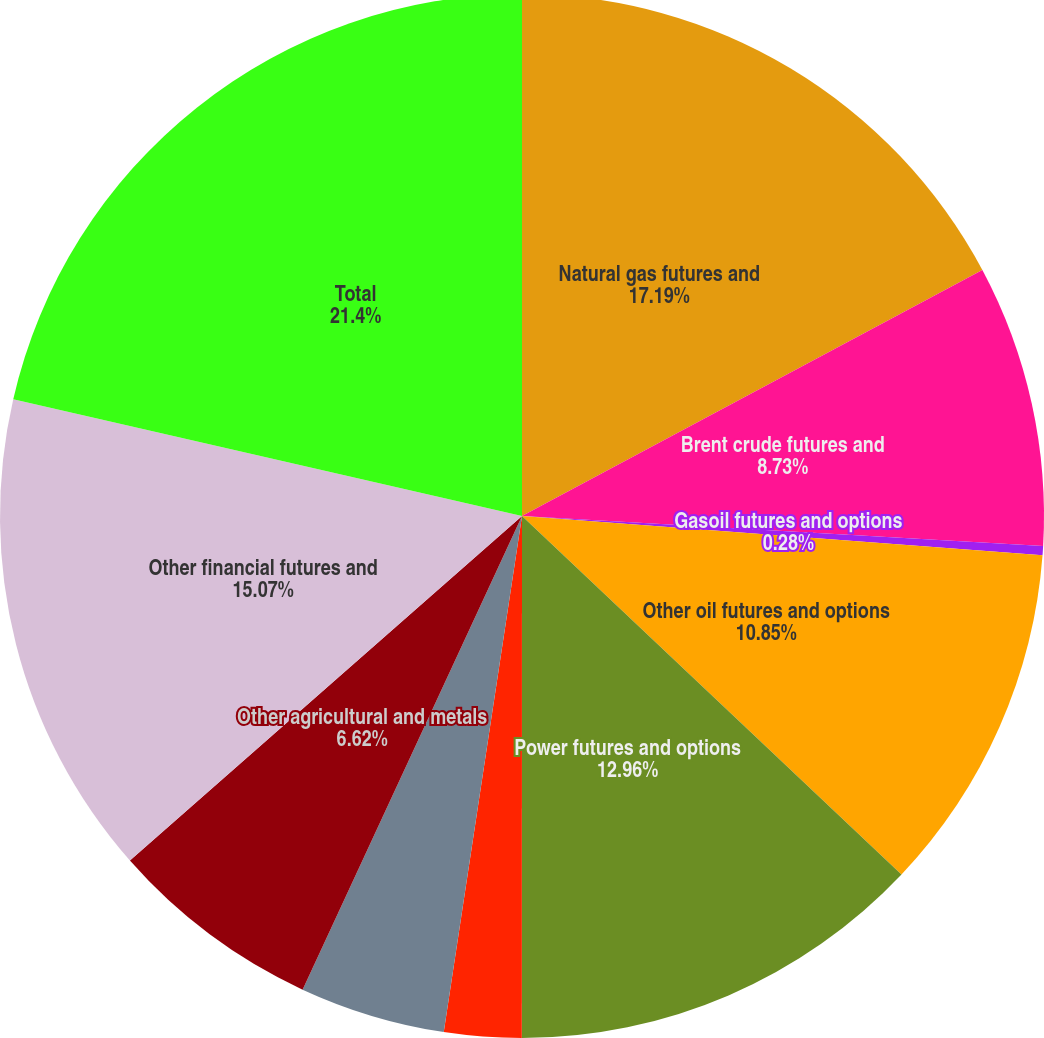<chart> <loc_0><loc_0><loc_500><loc_500><pie_chart><fcel>Natural gas futures and<fcel>Brent crude futures and<fcel>Gasoil futures and options<fcel>Other oil futures and options<fcel>Power futures and options<fcel>Emissions and other energy<fcel>Sugar futures and options<fcel>Other agricultural and metals<fcel>Other financial futures and<fcel>Total<nl><fcel>17.19%<fcel>8.73%<fcel>0.28%<fcel>10.85%<fcel>12.96%<fcel>2.39%<fcel>4.51%<fcel>6.62%<fcel>15.07%<fcel>21.41%<nl></chart> 